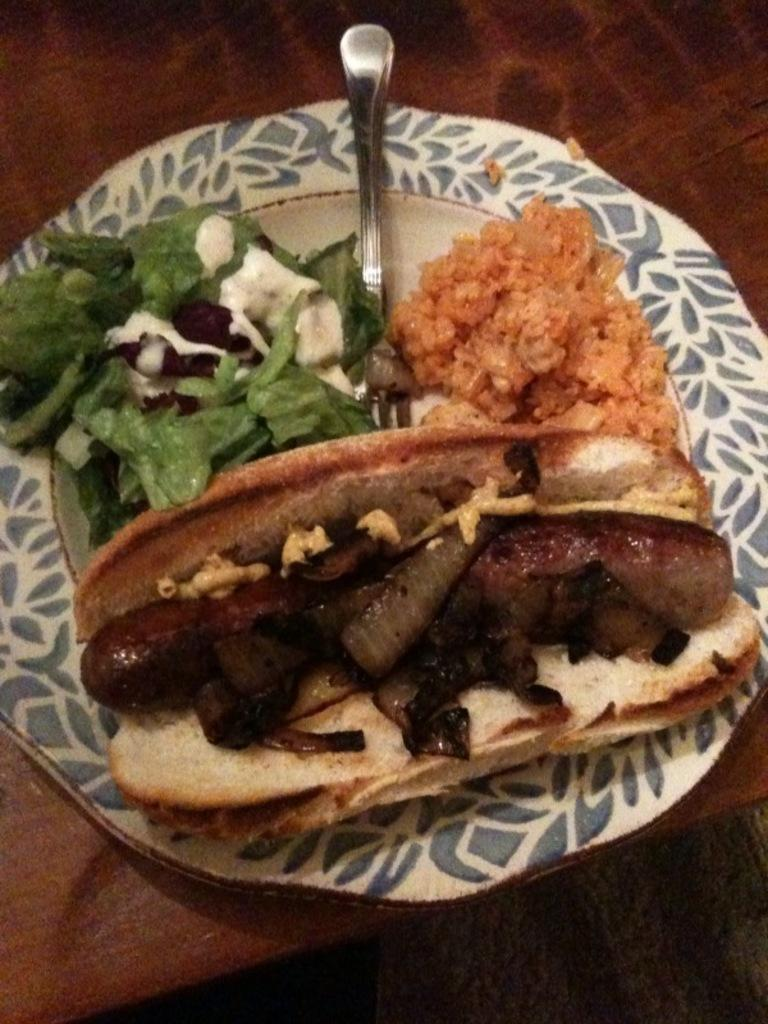What type of objects can be seen in the image? There are food items in the image. Can you describe the utensil present in the image? A fork is present in a plate in the image. What type of plot is being discussed in the image? There is no plot present in the image, as it features food items and a fork. What type of pickle can be seen in the image? There is no pickle present in the image. 